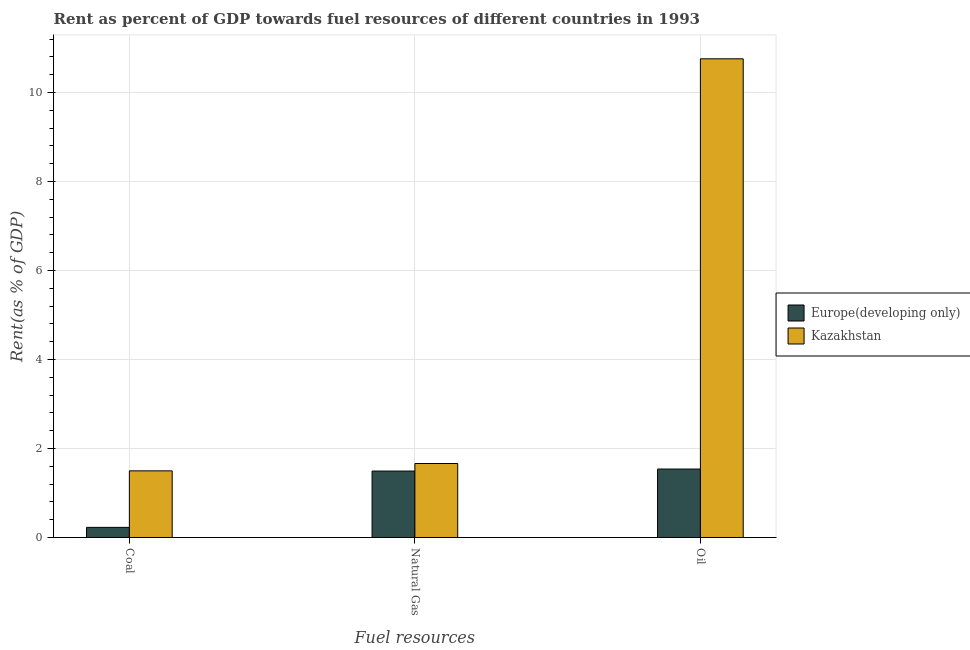How many different coloured bars are there?
Your answer should be compact. 2. Are the number of bars per tick equal to the number of legend labels?
Make the answer very short. Yes. Are the number of bars on each tick of the X-axis equal?
Keep it short and to the point. Yes. How many bars are there on the 2nd tick from the right?
Offer a terse response. 2. What is the label of the 1st group of bars from the left?
Provide a succinct answer. Coal. What is the rent towards coal in Europe(developing only)?
Your response must be concise. 0.23. Across all countries, what is the maximum rent towards natural gas?
Your response must be concise. 1.66. Across all countries, what is the minimum rent towards coal?
Ensure brevity in your answer.  0.23. In which country was the rent towards coal maximum?
Your answer should be very brief. Kazakhstan. In which country was the rent towards natural gas minimum?
Make the answer very short. Europe(developing only). What is the total rent towards natural gas in the graph?
Make the answer very short. 3.16. What is the difference between the rent towards natural gas in Europe(developing only) and that in Kazakhstan?
Provide a succinct answer. -0.17. What is the difference between the rent towards coal in Kazakhstan and the rent towards natural gas in Europe(developing only)?
Provide a succinct answer. 0. What is the average rent towards oil per country?
Provide a succinct answer. 6.15. What is the difference between the rent towards oil and rent towards natural gas in Kazakhstan?
Offer a very short reply. 9.1. In how many countries, is the rent towards coal greater than 10.8 %?
Give a very brief answer. 0. What is the ratio of the rent towards coal in Europe(developing only) to that in Kazakhstan?
Provide a short and direct response. 0.15. Is the difference between the rent towards natural gas in Kazakhstan and Europe(developing only) greater than the difference between the rent towards coal in Kazakhstan and Europe(developing only)?
Give a very brief answer. No. What is the difference between the highest and the second highest rent towards coal?
Your answer should be compact. 1.27. What is the difference between the highest and the lowest rent towards natural gas?
Offer a terse response. 0.17. Is the sum of the rent towards oil in Kazakhstan and Europe(developing only) greater than the maximum rent towards natural gas across all countries?
Provide a short and direct response. Yes. What does the 1st bar from the left in Natural Gas represents?
Your response must be concise. Europe(developing only). What does the 2nd bar from the right in Coal represents?
Provide a succinct answer. Europe(developing only). How many countries are there in the graph?
Give a very brief answer. 2. How many legend labels are there?
Ensure brevity in your answer.  2. How are the legend labels stacked?
Your response must be concise. Vertical. What is the title of the graph?
Your answer should be very brief. Rent as percent of GDP towards fuel resources of different countries in 1993. What is the label or title of the X-axis?
Offer a terse response. Fuel resources. What is the label or title of the Y-axis?
Make the answer very short. Rent(as % of GDP). What is the Rent(as % of GDP) in Europe(developing only) in Coal?
Make the answer very short. 0.23. What is the Rent(as % of GDP) of Kazakhstan in Coal?
Offer a terse response. 1.5. What is the Rent(as % of GDP) in Europe(developing only) in Natural Gas?
Ensure brevity in your answer.  1.49. What is the Rent(as % of GDP) in Kazakhstan in Natural Gas?
Provide a succinct answer. 1.66. What is the Rent(as % of GDP) of Europe(developing only) in Oil?
Provide a short and direct response. 1.54. What is the Rent(as % of GDP) of Kazakhstan in Oil?
Offer a terse response. 10.76. Across all Fuel resources, what is the maximum Rent(as % of GDP) in Europe(developing only)?
Offer a very short reply. 1.54. Across all Fuel resources, what is the maximum Rent(as % of GDP) in Kazakhstan?
Offer a very short reply. 10.76. Across all Fuel resources, what is the minimum Rent(as % of GDP) in Europe(developing only)?
Make the answer very short. 0.23. Across all Fuel resources, what is the minimum Rent(as % of GDP) in Kazakhstan?
Keep it short and to the point. 1.5. What is the total Rent(as % of GDP) in Europe(developing only) in the graph?
Your answer should be very brief. 3.26. What is the total Rent(as % of GDP) of Kazakhstan in the graph?
Your response must be concise. 13.92. What is the difference between the Rent(as % of GDP) of Europe(developing only) in Coal and that in Natural Gas?
Give a very brief answer. -1.27. What is the difference between the Rent(as % of GDP) of Kazakhstan in Coal and that in Natural Gas?
Ensure brevity in your answer.  -0.17. What is the difference between the Rent(as % of GDP) in Europe(developing only) in Coal and that in Oil?
Keep it short and to the point. -1.31. What is the difference between the Rent(as % of GDP) of Kazakhstan in Coal and that in Oil?
Offer a terse response. -9.26. What is the difference between the Rent(as % of GDP) in Europe(developing only) in Natural Gas and that in Oil?
Ensure brevity in your answer.  -0.05. What is the difference between the Rent(as % of GDP) of Kazakhstan in Natural Gas and that in Oil?
Offer a terse response. -9.1. What is the difference between the Rent(as % of GDP) of Europe(developing only) in Coal and the Rent(as % of GDP) of Kazakhstan in Natural Gas?
Your answer should be very brief. -1.44. What is the difference between the Rent(as % of GDP) of Europe(developing only) in Coal and the Rent(as % of GDP) of Kazakhstan in Oil?
Your response must be concise. -10.53. What is the difference between the Rent(as % of GDP) of Europe(developing only) in Natural Gas and the Rent(as % of GDP) of Kazakhstan in Oil?
Your answer should be very brief. -9.27. What is the average Rent(as % of GDP) in Europe(developing only) per Fuel resources?
Ensure brevity in your answer.  1.09. What is the average Rent(as % of GDP) of Kazakhstan per Fuel resources?
Ensure brevity in your answer.  4.64. What is the difference between the Rent(as % of GDP) of Europe(developing only) and Rent(as % of GDP) of Kazakhstan in Coal?
Give a very brief answer. -1.27. What is the difference between the Rent(as % of GDP) in Europe(developing only) and Rent(as % of GDP) in Kazakhstan in Natural Gas?
Provide a succinct answer. -0.17. What is the difference between the Rent(as % of GDP) of Europe(developing only) and Rent(as % of GDP) of Kazakhstan in Oil?
Your response must be concise. -9.22. What is the ratio of the Rent(as % of GDP) in Europe(developing only) in Coal to that in Natural Gas?
Keep it short and to the point. 0.15. What is the ratio of the Rent(as % of GDP) of Kazakhstan in Coal to that in Natural Gas?
Ensure brevity in your answer.  0.9. What is the ratio of the Rent(as % of GDP) of Europe(developing only) in Coal to that in Oil?
Your answer should be very brief. 0.15. What is the ratio of the Rent(as % of GDP) of Kazakhstan in Coal to that in Oil?
Offer a very short reply. 0.14. What is the ratio of the Rent(as % of GDP) of Europe(developing only) in Natural Gas to that in Oil?
Give a very brief answer. 0.97. What is the ratio of the Rent(as % of GDP) of Kazakhstan in Natural Gas to that in Oil?
Provide a succinct answer. 0.15. What is the difference between the highest and the second highest Rent(as % of GDP) in Europe(developing only)?
Provide a succinct answer. 0.05. What is the difference between the highest and the second highest Rent(as % of GDP) in Kazakhstan?
Your answer should be compact. 9.1. What is the difference between the highest and the lowest Rent(as % of GDP) in Europe(developing only)?
Ensure brevity in your answer.  1.31. What is the difference between the highest and the lowest Rent(as % of GDP) of Kazakhstan?
Provide a succinct answer. 9.26. 